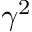<formula> <loc_0><loc_0><loc_500><loc_500>\gamma ^ { 2 }</formula> 